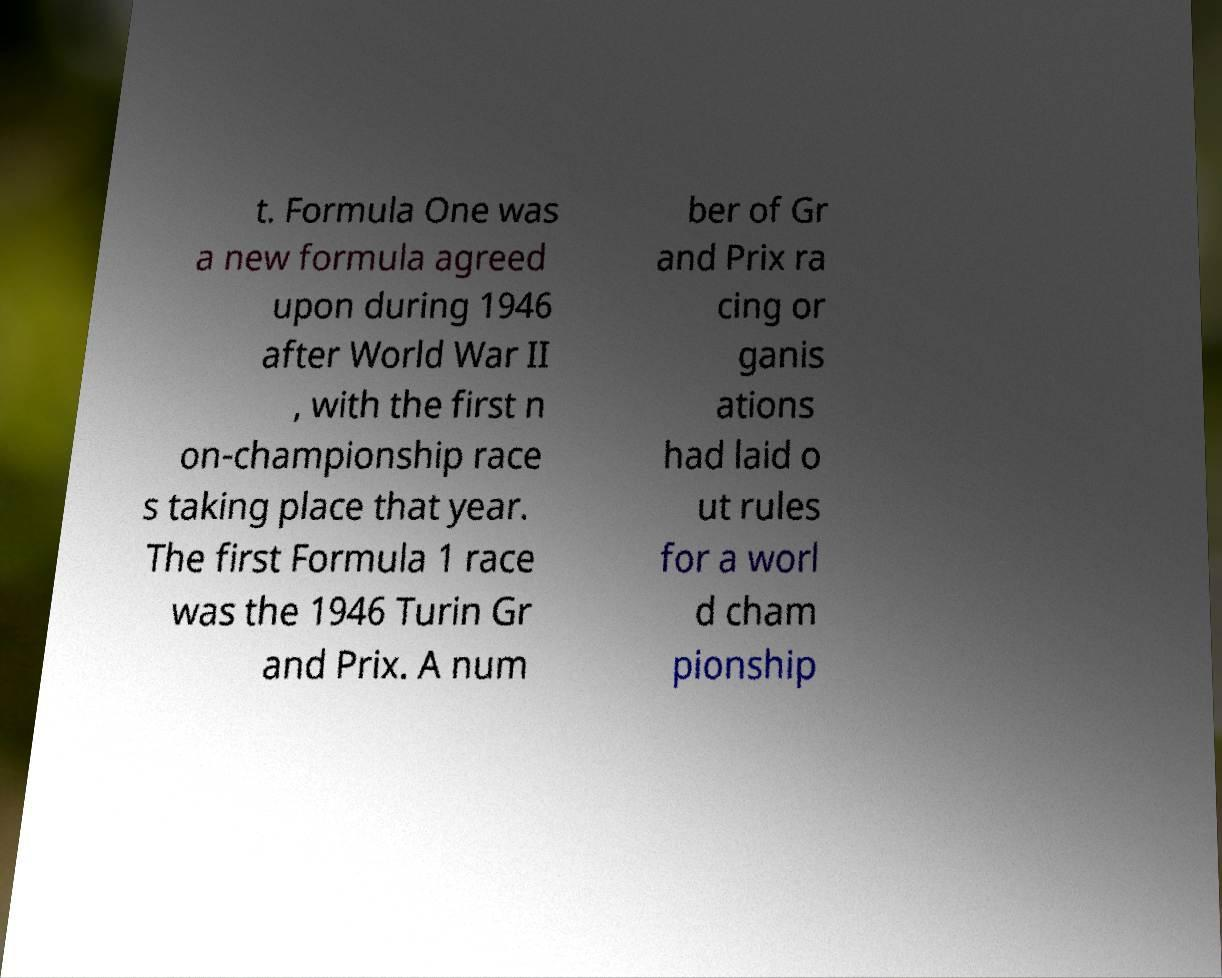Could you extract and type out the text from this image? t. Formula One was a new formula agreed upon during 1946 after World War II , with the first n on-championship race s taking place that year. The first Formula 1 race was the 1946 Turin Gr and Prix. A num ber of Gr and Prix ra cing or ganis ations had laid o ut rules for a worl d cham pionship 